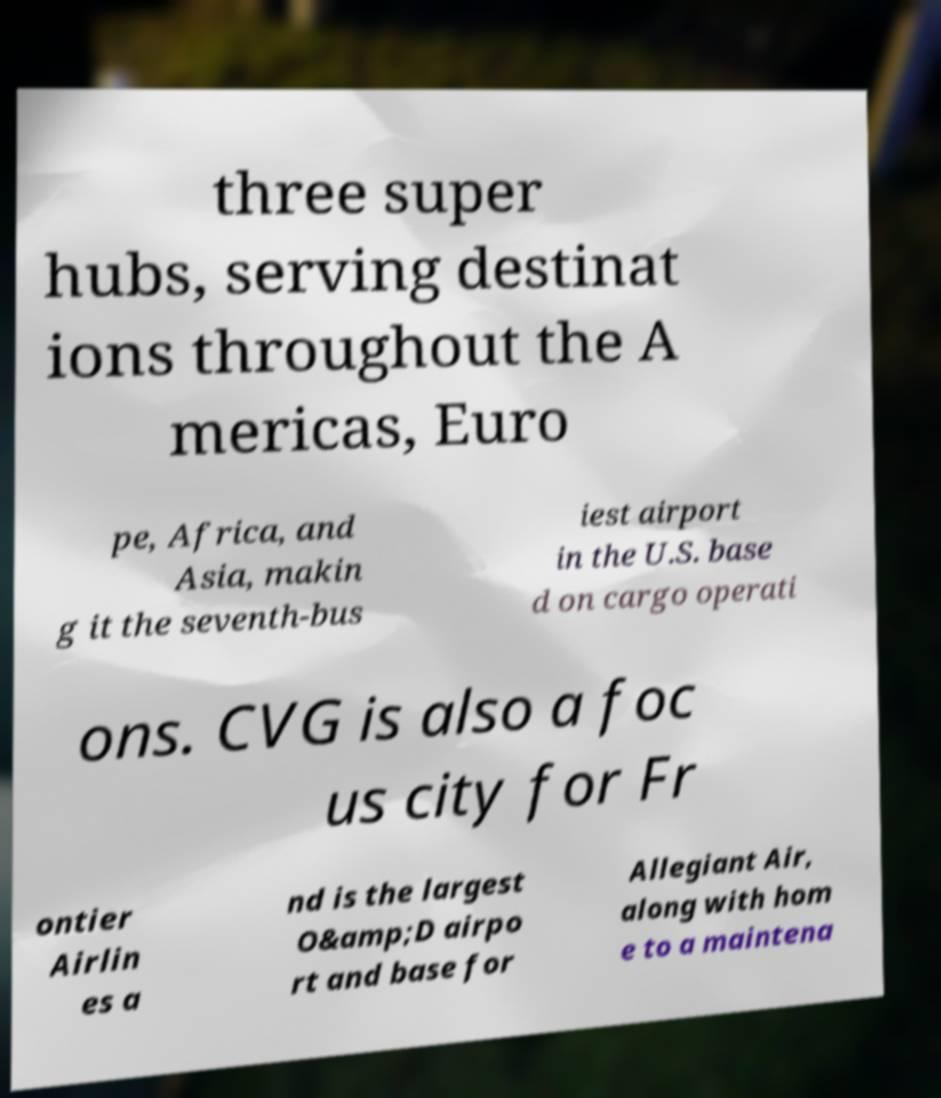For documentation purposes, I need the text within this image transcribed. Could you provide that? three super hubs, serving destinat ions throughout the A mericas, Euro pe, Africa, and Asia, makin g it the seventh-bus iest airport in the U.S. base d on cargo operati ons. CVG is also a foc us city for Fr ontier Airlin es a nd is the largest O&amp;D airpo rt and base for Allegiant Air, along with hom e to a maintena 